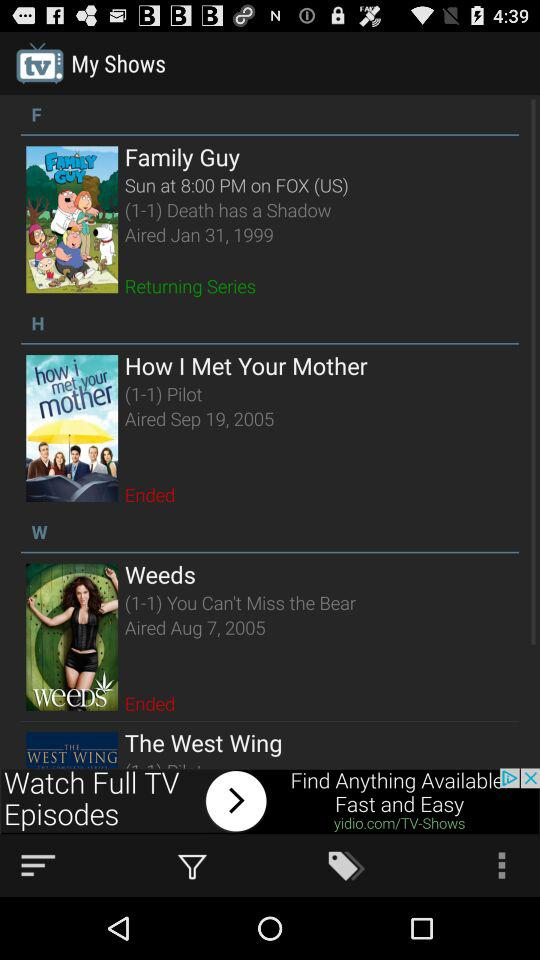In what year was the series "How I Met Your Mother" released? "How I Met Your Mother" was released in 2005. 